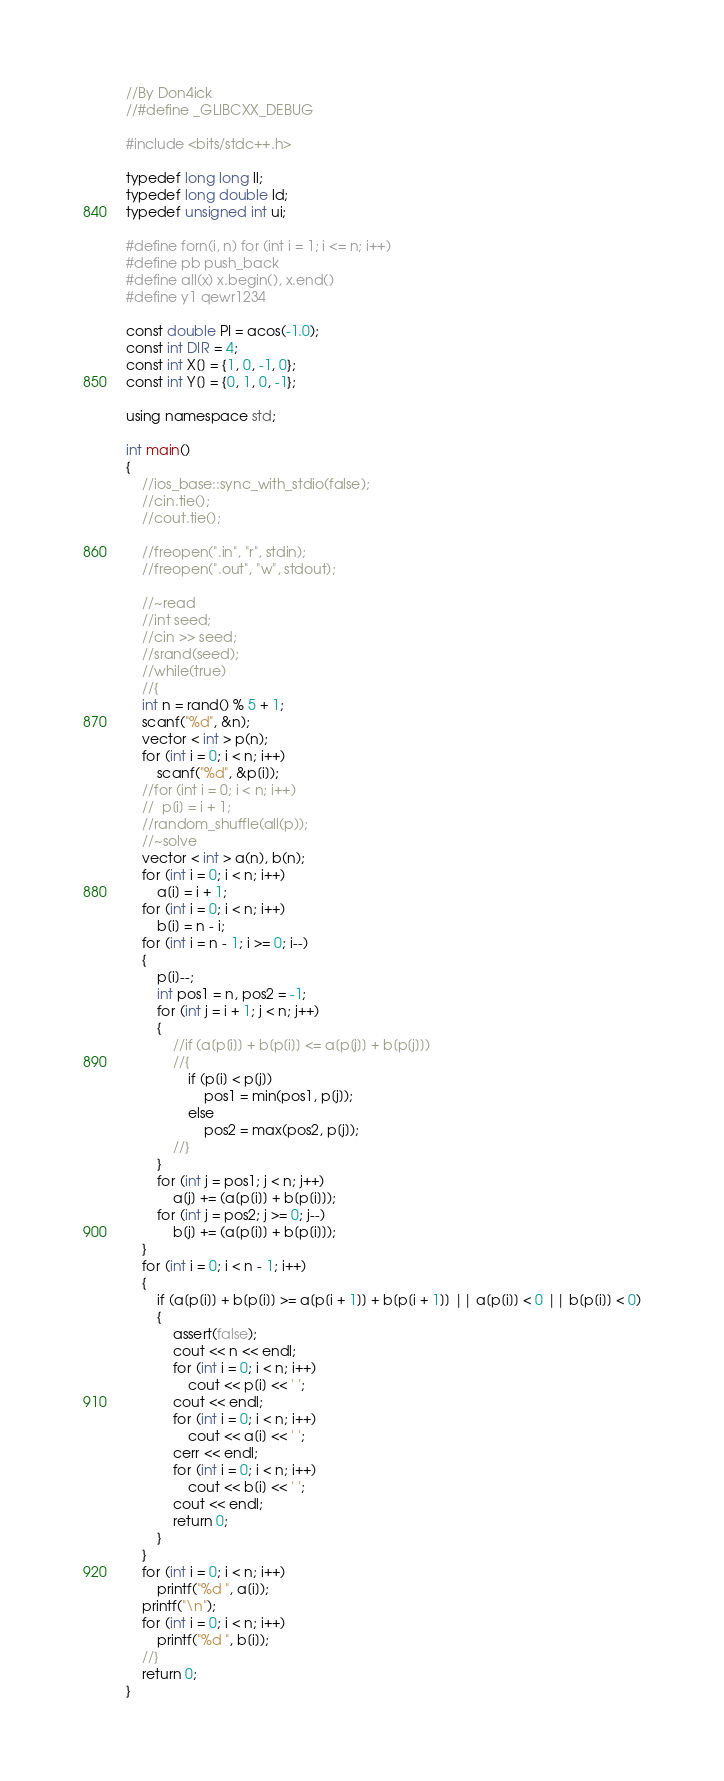Convert code to text. <code><loc_0><loc_0><loc_500><loc_500><_C++_>//By Don4ick 
//#define _GLIBCXX_DEBUG

#include <bits/stdc++.h>

typedef long long ll;
typedef long double ld;
typedef unsigned int ui;

#define forn(i, n) for (int i = 1; i <= n; i++)
#define pb push_back
#define all(x) x.begin(), x.end()
#define y1 qewr1234

const double PI = acos(-1.0);
const int DIR = 4;
const int X[] = {1, 0, -1, 0};
const int Y[] = {0, 1, 0, -1};

using namespace std;

int main()
{
	//ios_base::sync_with_stdio(false);
	//cin.tie();
	//cout.tie();		

	//freopen(".in", "r", stdin);
	//freopen(".out", "w", stdout);

	//~read
	//int seed;
	//cin >> seed;
	//srand(seed);
	//while(true)
	//{
	int n = rand() % 5 + 1;
	scanf("%d", &n);
	vector < int > p(n);
	for (int i = 0; i < n; i++)
		scanf("%d", &p[i]);
	//for (int i = 0; i < n; i++)
	//	p[i] = i + 1;	
	//random_shuffle(all(p));
	//~solve
	vector < int > a(n), b(n);
	for (int i = 0; i < n; i++)
		a[i] = i + 1;
	for (int i = 0; i < n; i++)
		b[i] = n - i;
	for (int i = n - 1; i >= 0; i--)
	{	
		p[i]--;
		int pos1 = n, pos2 = -1;
		for (int j = i + 1; j < n; j++)
		{
			//if (a[p[i]] + b[p[i]] <= a[p[j]] + b[p[j]])
			//{
				if (p[i] < p[j])
					pos1 = min(pos1, p[j]);
				else
					pos2 = max(pos2, p[j]);
			//}										
		}
		for (int j = pos1; j < n; j++)
			a[j] += (a[p[i]] + b[p[i]]);
		for (int j = pos2; j >= 0; j--)
			b[j] += (a[p[i]] + b[p[i]]);
	}
	for (int i = 0; i < n - 1; i++)	
	{
		if (a[p[i]] + b[p[i]] >= a[p[i + 1]] + b[p[i + 1]] || a[p[i]] < 0 || b[p[i]] < 0)
		{
			assert(false);
			cout << n << endl;
			for (int i = 0; i < n; i++)
				cout << p[i] << ' ';
	        cout << endl;
			for (int i = 0; i < n; i++)
				cout << a[i] << ' ';
			cerr << endl;
			for (int i = 0; i < n; i++)
				cout << b[i] << ' ';
			cout << endl;
			return 0;
		}
	}
	for (int i = 0; i < n; i++)
		printf("%d ", a[i]);
	printf("\n");
	for (int i = 0; i < n; i++)
		printf("%d ", b[i]);
	//}
	return 0;
}

</code> 